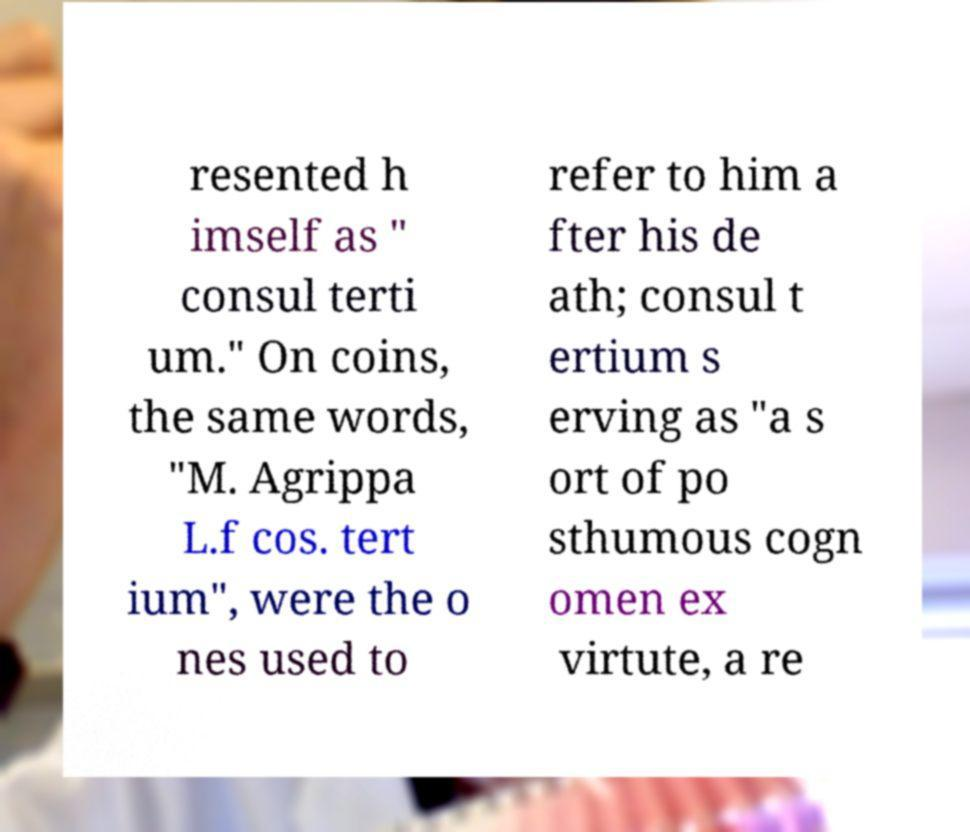Could you extract and type out the text from this image? resented h imself as " consul terti um." On coins, the same words, "M. Agrippa L.f cos. tert ium", were the o nes used to refer to him a fter his de ath; consul t ertium s erving as "a s ort of po sthumous cogn omen ex virtute, a re 